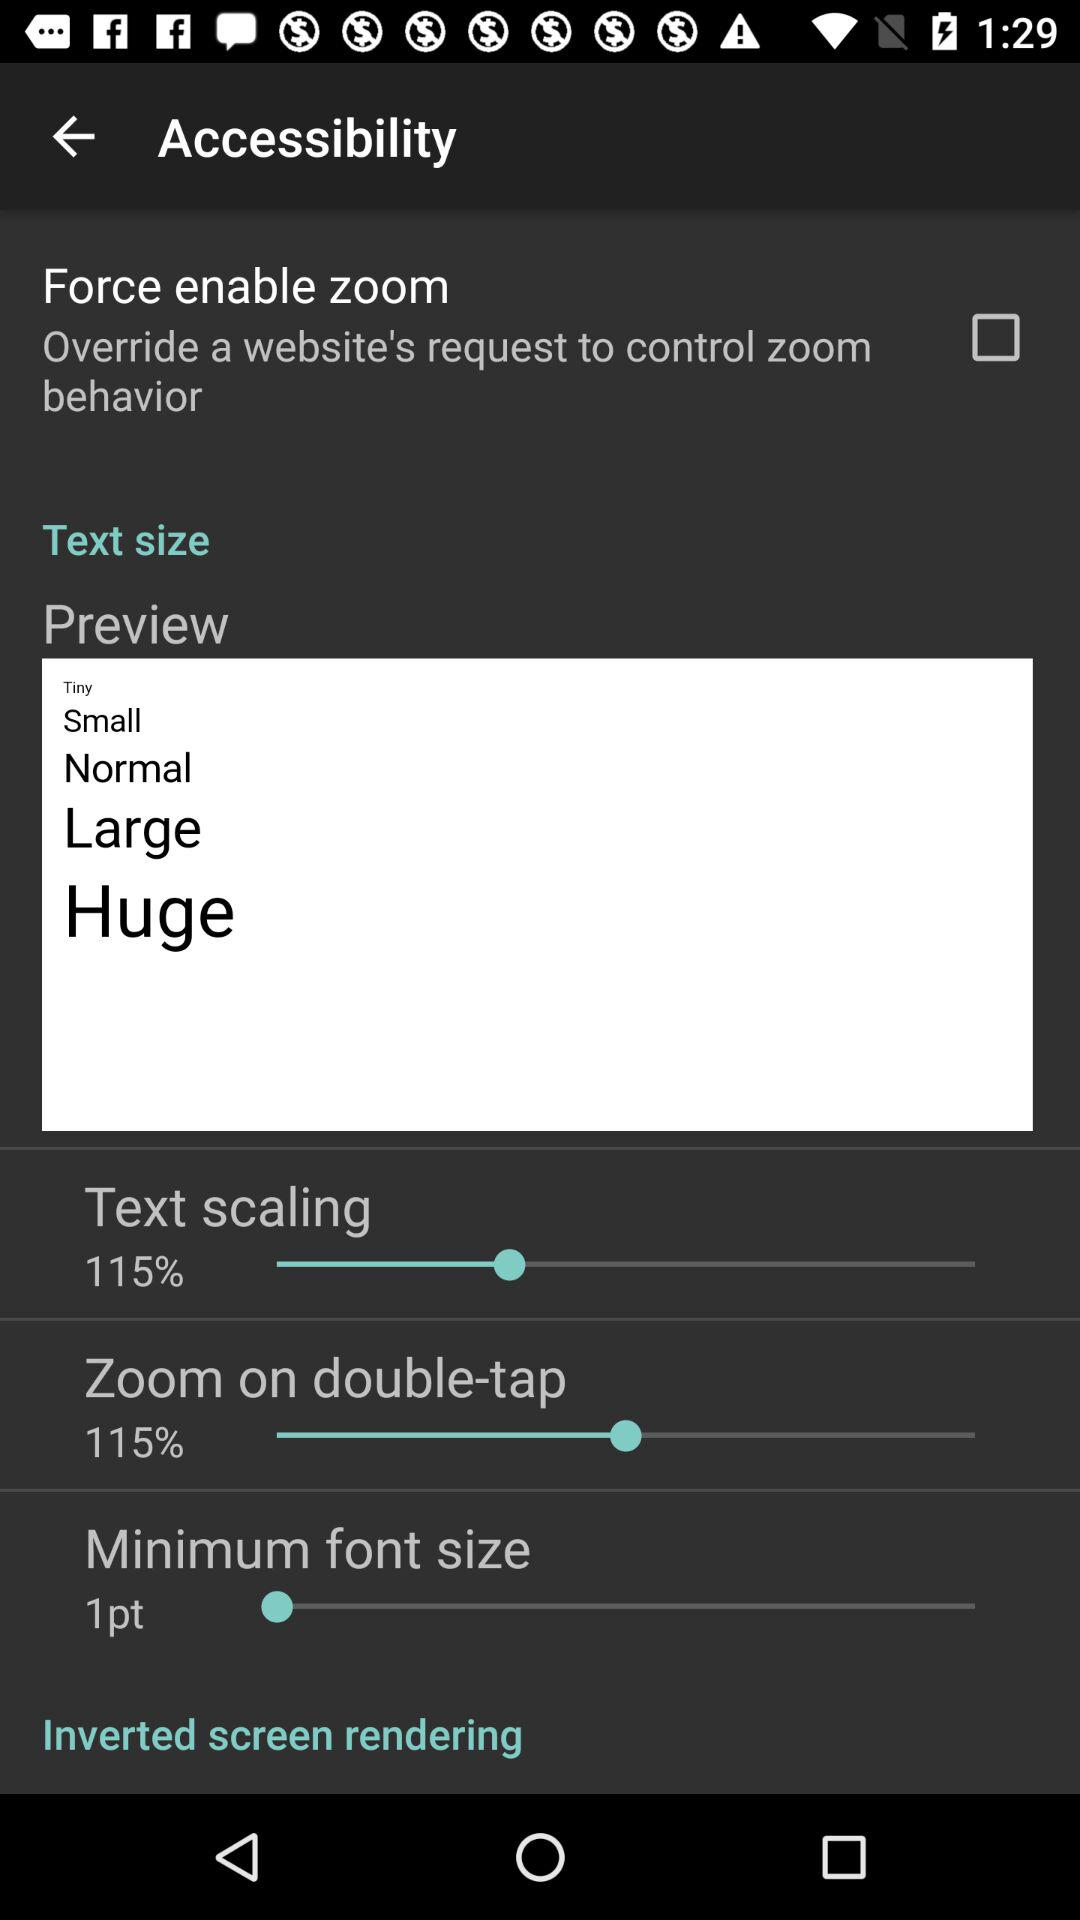What is the value of “Zoom on double-tap”? The value of "Zoom on double-tap" is 115%. 